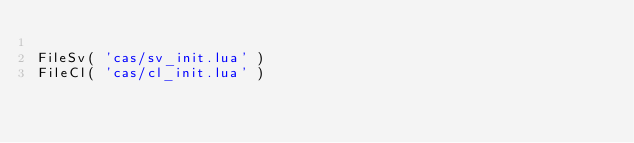<code> <loc_0><loc_0><loc_500><loc_500><_Lua_>
FileSv( 'cas/sv_init.lua' )
FileCl( 'cas/cl_init.lua' )
</code> 